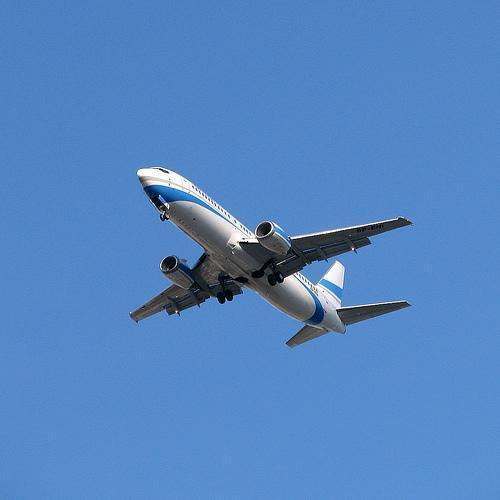How many planes are crashing in this picture?
Give a very brief answer. 0. 